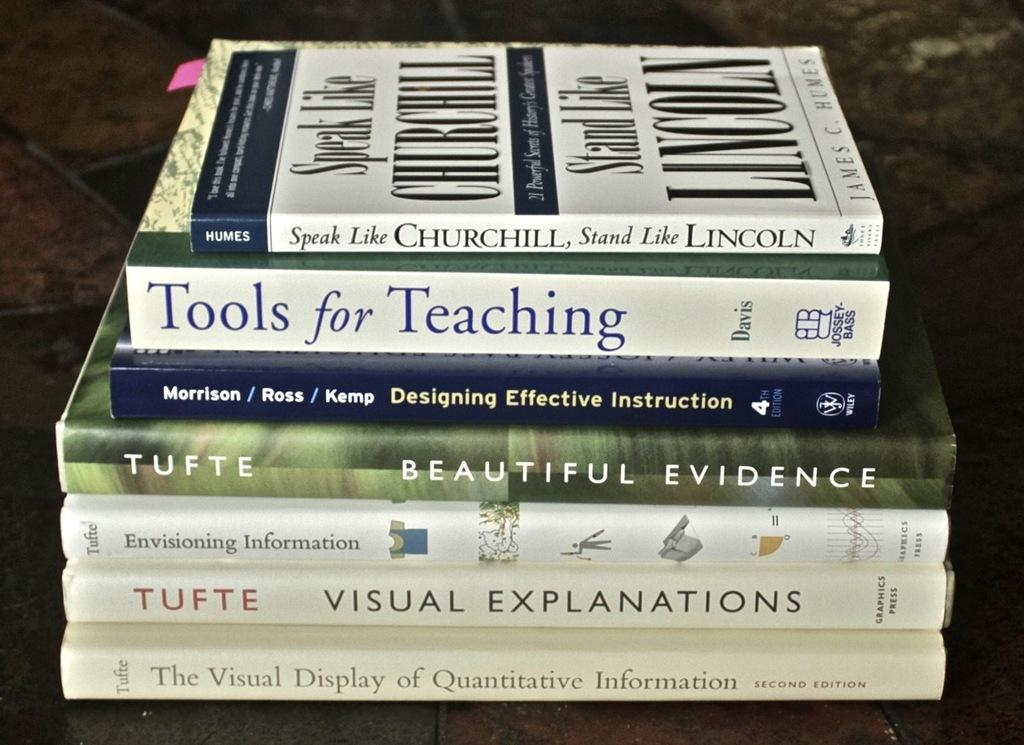<image>
Describe the image concisely. Books on top of one another with one that says "Tools for Teaching" on top. 